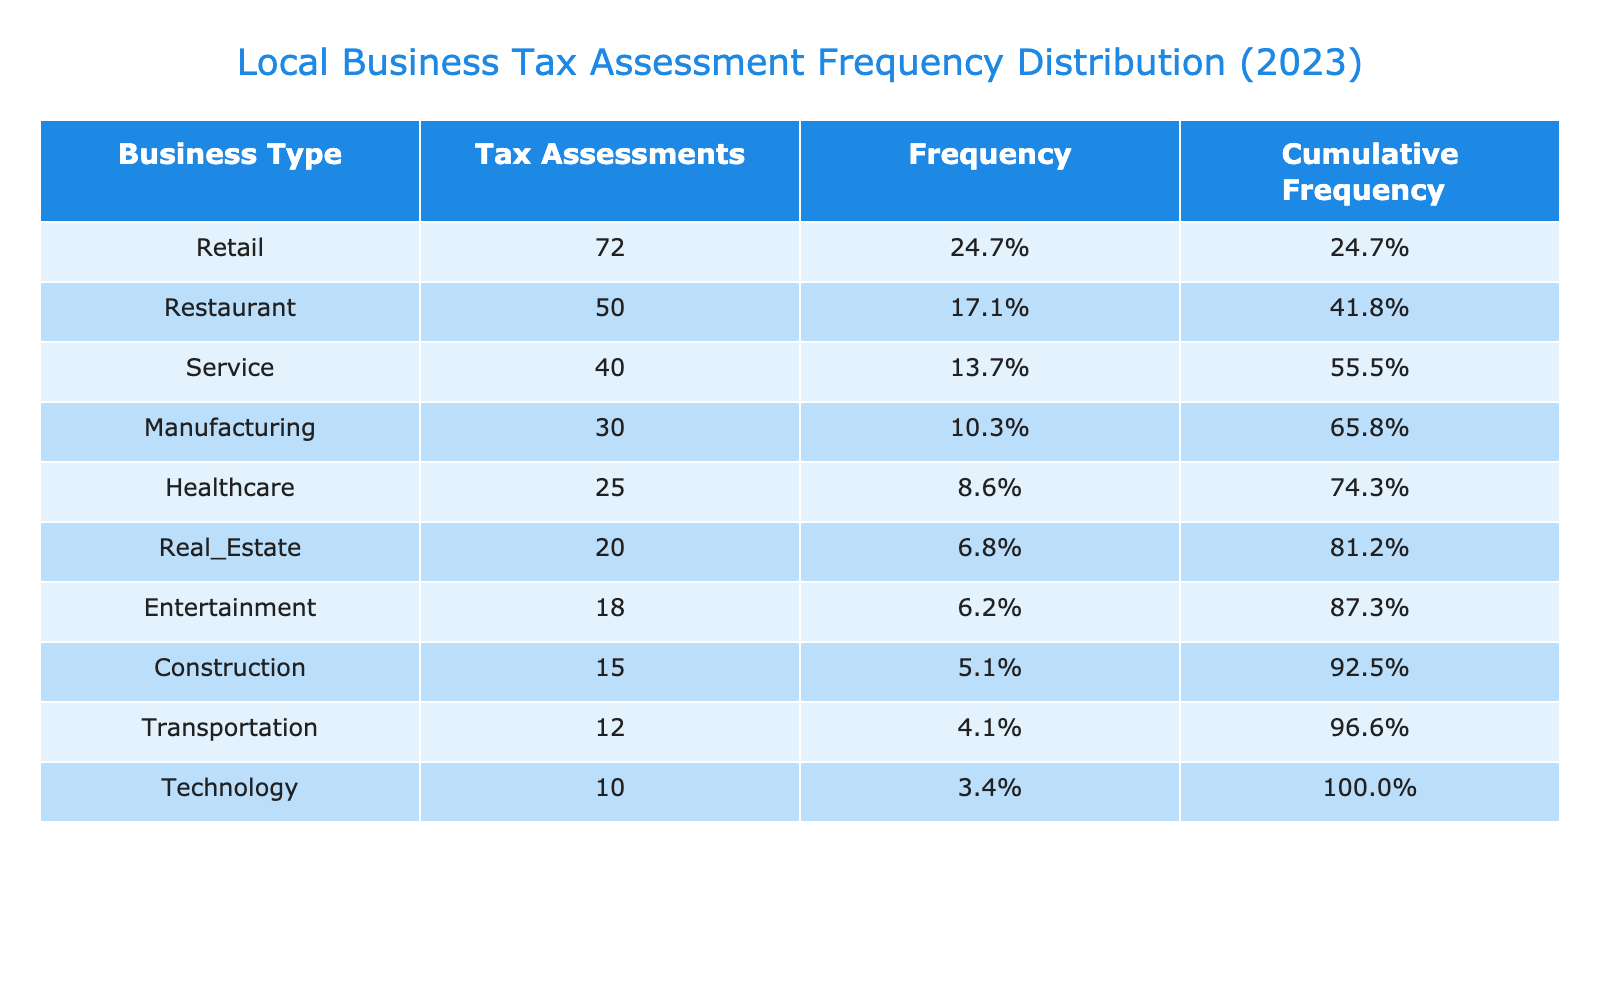What business type has the highest number of tax assessments? The table shows that the Restaurant business type has the highest number of tax assessments, which is 50.
Answer: Restaurant What is the total number of tax assessments for all business types? To find the total, we sum all the tax assessments: 50 + 72 + 40 + 30 + 15 + 25 + 10 + 20 + 18 + 12 = 332.
Answer: 332 Which business type has the lowest frequency of tax assessments? The Technology business type has the lowest tax assessments at 10, leading to the lowest frequency.
Answer: Technology Is the number of tax assessments for Retail greater than the combined assessments of Healthcare and Technology? The Retail has 72 tax assessments, while Healthcare has 25 and Technology has 10. Combining those gives 25 + 10 = 35, which is less than 72, making it true.
Answer: Yes What is the frequency of the Construction business type? The frequency is calculated as the number of assessments (15) divided by the total (332), giving approximately 4.5%.
Answer: 4.5% 